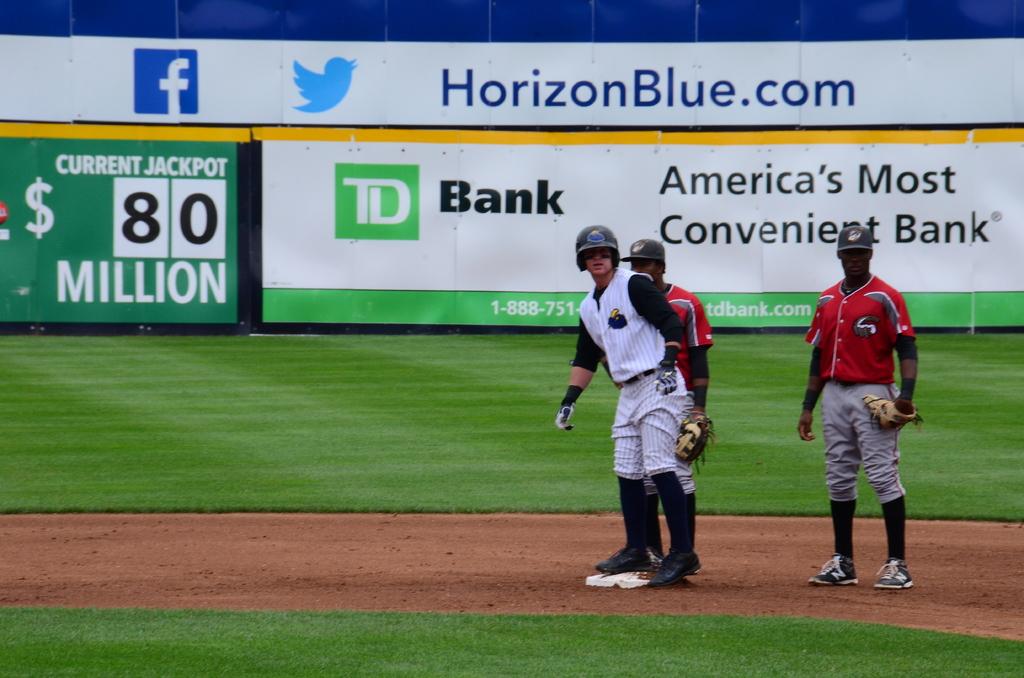What is the website on the wall?
Give a very brief answer. Horizonblue.com. What bank is a sponsor?
Your response must be concise. Td bank. 